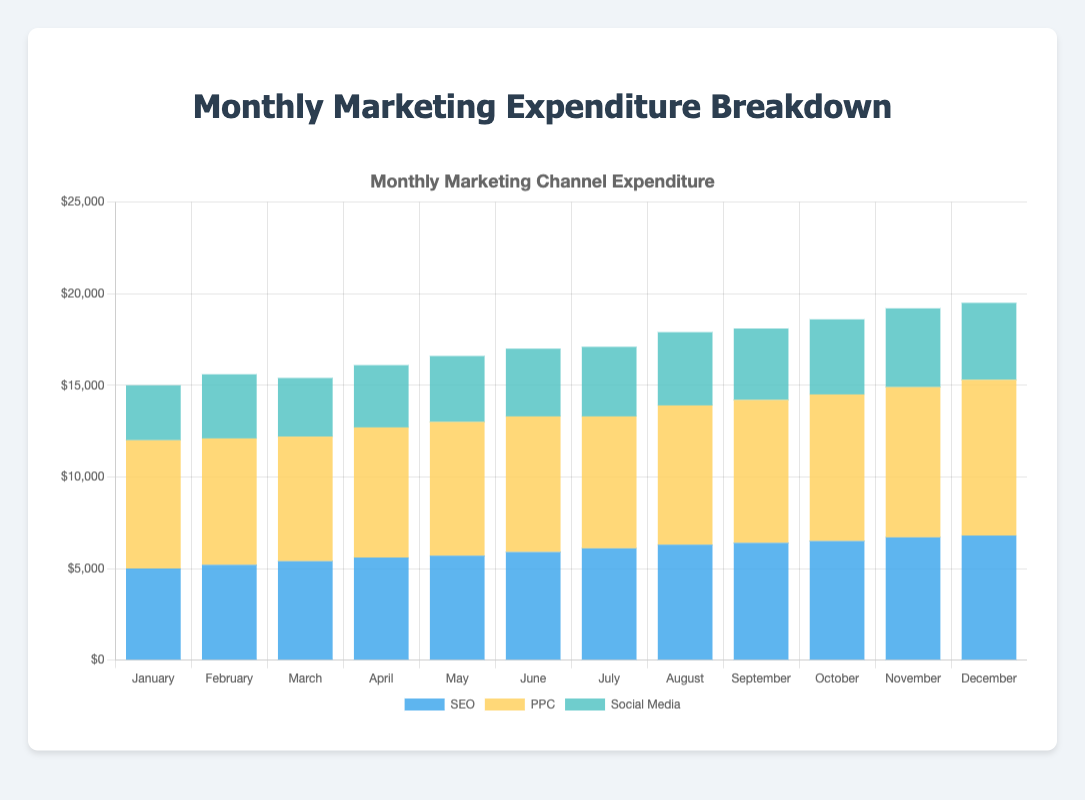Which month has the highest expenditure in PPC? By examining the height of the PPC section (yellow) in each month's stacked bar, the tallest bar segment corresponds to December. The expenditure for PPC in December is $8500, the highest among all months.
Answer: December What's the total expenditure on SEO and Social Media in March? To find the total expenditure on SEO and Social Media in March, sum the heights of the blue and green segments for March. SEO is $5400, and Social Media is $3200. Add them together: $5400 + $3200 = $8600.
Answer: $8600 Which marketing channel had the lowest expenditure in January? In January, compare the heights of the blue (SEO), yellow (PPC), and green (Social Media) bar segments. The green bar (Social Media) is the shortest, indicating it had the lowest expenditure.
Answer: Social Media What is the average monthly expenditure on SEO over the first quarter (January to March)? The expenditure on SEO in January is $5000, February is $5200, and March is $5400. Sum these amounts: $5000 + $5200 + $5400 = $15600. Then, divide by 3 (number of months): $15600 / 3 = $5200.
Answer: $5200 In which months did Social Media expenditure exceed $4000? Examine the green segments (Social Media) and identify which ones are greater than $4000. These are visible in the months August ($4000), September ($3900), October ($4100), November ($4300), and December ($4200). Note: Only October, November, and December exceed $4000.
Answer: October, November, December Compare the difference in total expenditure between January and December. Total January expenditure: SEO ($5000) + PPC ($7000) + Social Media ($3000) = $15000. Total December expenditure: SEO ($6800) + PPC ($8500) + Social Media ($4200) = $19500. Difference: $19500 - $15000 = $4500.
Answer: $4500 What's the cumulative expenditure on PPC from July to December? Sum the PPC expenditures from July ($7200), August ($7600), September ($7800), October ($8000), November ($8200), and December ($8500): $7200 + $7600 + $7800 + $8000 + $8200 + $8500 = $47300.
Answer: $47300 Which month shows the greatest increase in SEO expenditure compared to the previous month? Calculate the month-to-month increases in SEO expenditure: February to January ($5200 - $5000 = $200), March to February ($5400 - $5200 = $200), April to March ($5600 - $5400 = $200), May to April ($5700 - $5600 = $100), June to May ($5900 - $5700 = $200), July to June ($6100 - $5900 = $200), August to July ($6300 - $6100 = $200), September to August ($6400 - $6300 = $100), October to September ($6500 - $6400 = $100), November to October ($6700 - $6500 = $200), December to November ($6800 - $6700 = $100). All increases are $200 except for May, September, October, and December, therefore, they show no greatest individual month.
Answer: No greatest individual month What's the combined total of all marketing expenditures in February? Sum the expenditures on SEO ($5200), PPC ($6900), and Social Media ($3500) for February: $5200 + $6900 + $3500 = $15600.
Answer: $15600 